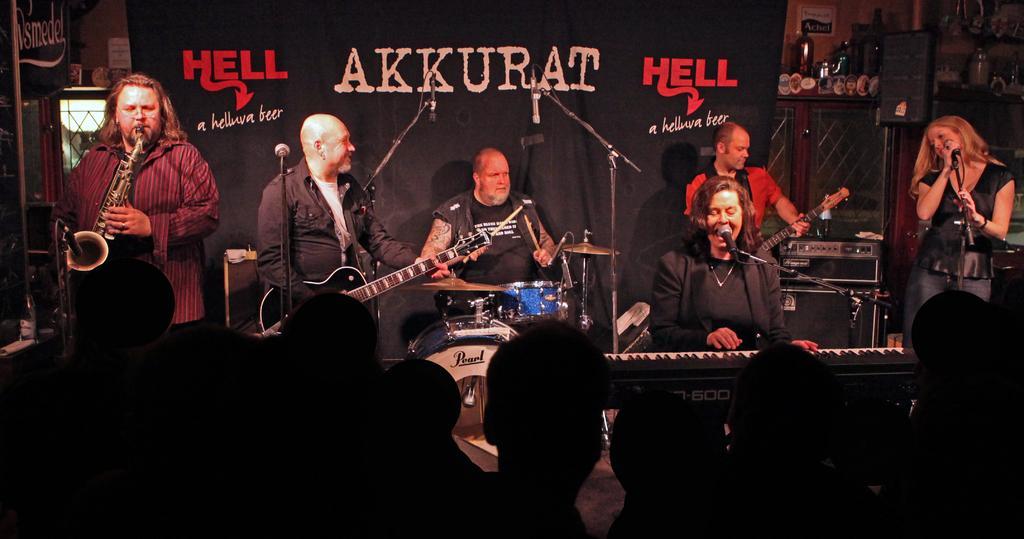In one or two sentences, can you explain what this image depicts? This picture is of inside the room. On the right there is a woman wearing black color t-shirt standing and holding a microphone which is attached to the stand. There is a woman wearing black color t-shirt, sitting, playing piano and seems to be singing, behind her there is a man wearing red color t-shirt, standing and playing guitar. In the center there is a man wearing black color t-shirt, sitting and playing drums, beside him there is a man wearing black color shirt, standing and playing guitar. There is a microphone attached to the stand. On the left there is a man wearing red color shirt, standing and playing trumpet. In the background there is a wall and a black color banner and we can see a cabinet on the top of which some items are placed. 